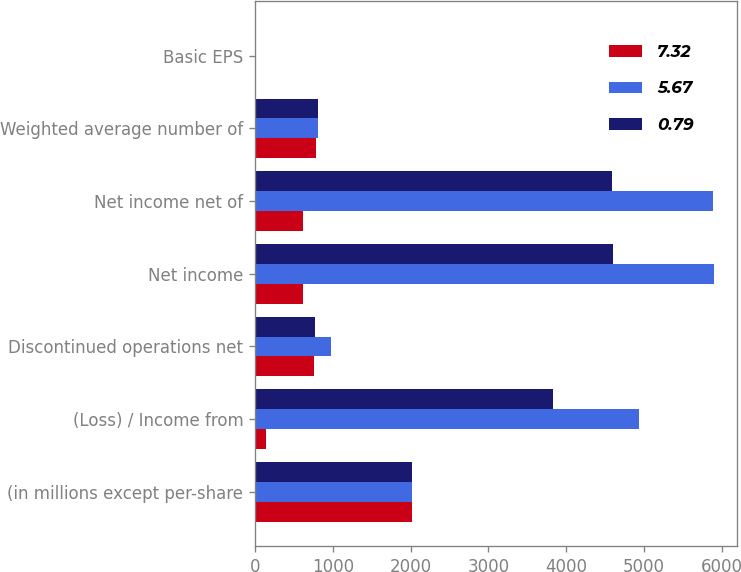Convert chart to OTSL. <chart><loc_0><loc_0><loc_500><loc_500><stacked_bar_chart><ecel><fcel>(in millions except per-share<fcel>(Loss) / Income from<fcel>Discontinued operations net<fcel>Net income<fcel>Net income net of<fcel>Weighted average number of<fcel>Basic EPS<nl><fcel>7.32<fcel>2014<fcel>144<fcel>760<fcel>616<fcel>616<fcel>781.1<fcel>0.79<nl><fcel>5.67<fcel>2013<fcel>4932<fcel>971<fcel>5903<fcel>5890<fcel>804.1<fcel>7.33<nl><fcel>0.79<fcel>2012<fcel>3829<fcel>769<fcel>4598<fcel>4590<fcel>809.3<fcel>5.67<nl></chart> 